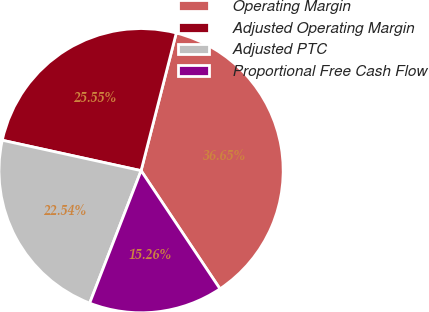Convert chart to OTSL. <chart><loc_0><loc_0><loc_500><loc_500><pie_chart><fcel>Operating Margin<fcel>Adjusted Operating Margin<fcel>Adjusted PTC<fcel>Proportional Free Cash Flow<nl><fcel>36.65%<fcel>25.55%<fcel>22.54%<fcel>15.26%<nl></chart> 